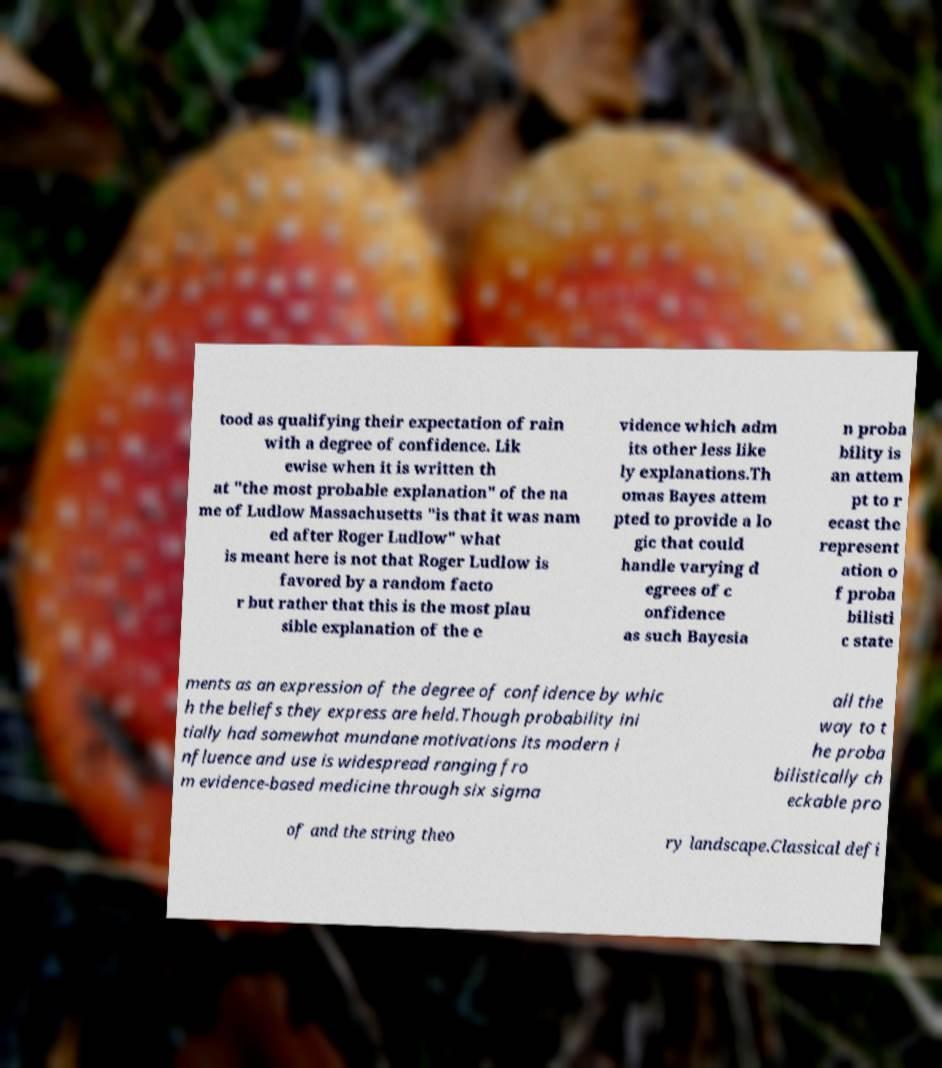Can you accurately transcribe the text from the provided image for me? tood as qualifying their expectation of rain with a degree of confidence. Lik ewise when it is written th at "the most probable explanation" of the na me of Ludlow Massachusetts "is that it was nam ed after Roger Ludlow" what is meant here is not that Roger Ludlow is favored by a random facto r but rather that this is the most plau sible explanation of the e vidence which adm its other less like ly explanations.Th omas Bayes attem pted to provide a lo gic that could handle varying d egrees of c onfidence as such Bayesia n proba bility is an attem pt to r ecast the represent ation o f proba bilisti c state ments as an expression of the degree of confidence by whic h the beliefs they express are held.Though probability ini tially had somewhat mundane motivations its modern i nfluence and use is widespread ranging fro m evidence-based medicine through six sigma all the way to t he proba bilistically ch eckable pro of and the string theo ry landscape.Classical defi 